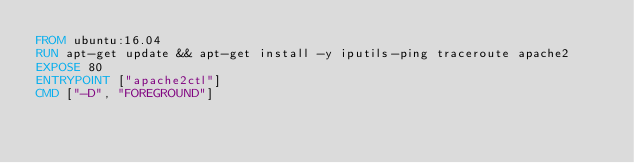<code> <loc_0><loc_0><loc_500><loc_500><_Dockerfile_>FROM ubuntu:16.04
RUN apt-get update && apt-get install -y iputils-ping traceroute apache2
EXPOSE 80
ENTRYPOINT ["apache2ctl"]
CMD ["-D", "FOREGROUND"]

</code> 